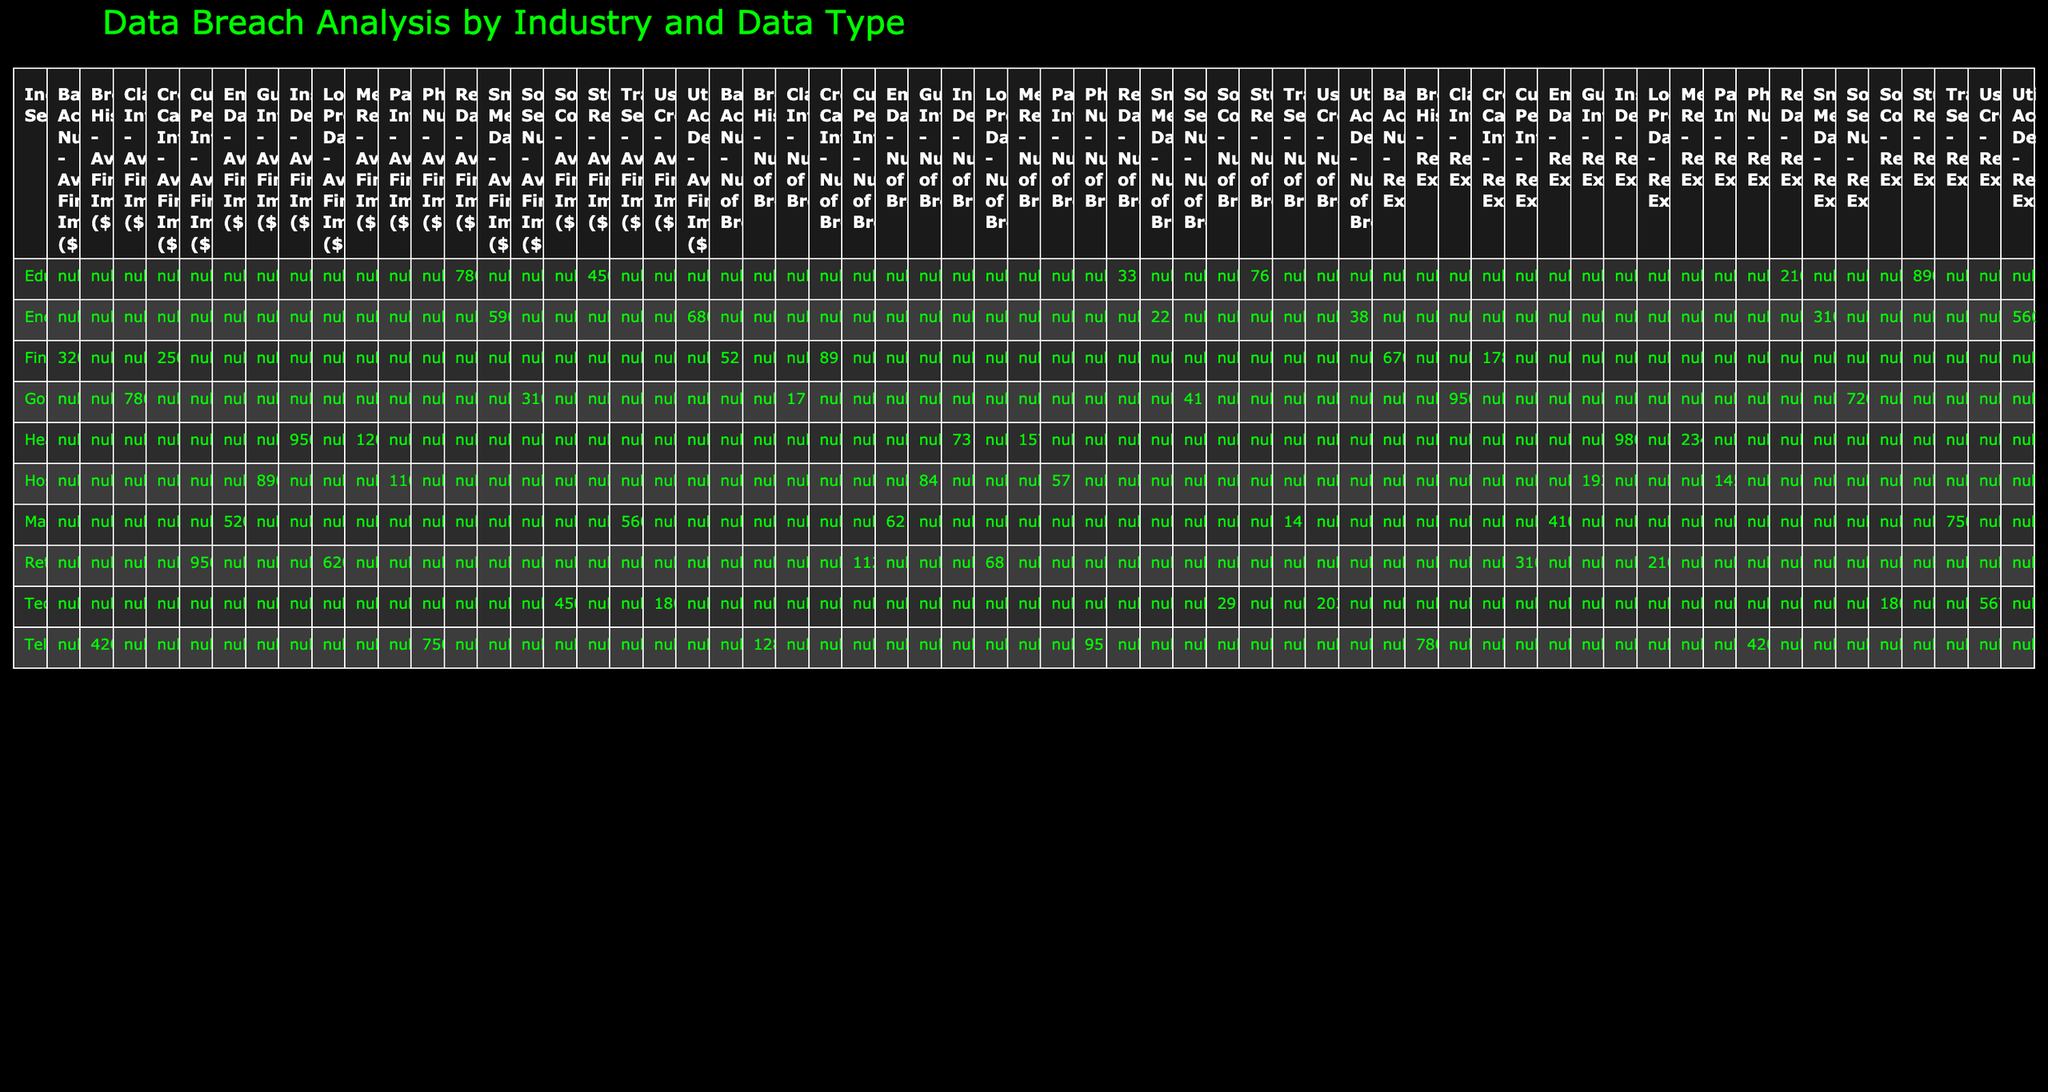What industry sector had the highest number of breaches? By looking at the "Number of Breaches" column for each industry sector, the Technology sector has the highest count with 203 breaches.
Answer: Technology What is the average financial impact of data breaches in the Government sector? The average financial impact for the Government sector is given as $3,100,000 for Social Security Numbers and $7,800,000 for Classified Information. To find the average, we calculate (3,100,000 + 7,800,000) / 2 = 5,450,000.
Answer: 5,450,000 Which data type in the Healthcare sector had the most records exposed? In the Healthcare sector, the Medical Records had 2,345,000 records exposed, while the Insurance Details had 980,000 records exposed. Therefore, Medical Records had the most records exposed.
Answer: Medical Records Did the Retail sector have more breaches of Customer Personal Info than Technology had user credentials breaches? The Retail sector had 112 breaches of Customer Personal Info, while the Technology sector had 203 breaches of user credentials. Since 112 < 203, the statement is false.
Answer: No What was the total number of records exposed across all sectors for Employee Data? The only sector with Employee Data is Manufacturing, which had 410,000 records exposed. Therefore, the total number of records exposed for this data type is 410,000.
Answer: 410,000 What sector had the least number of breaches for Utility Account Details? The only sector that reported breaches for Utility Account Details is Energy, with 38 breaches. Since no other sector is listed for this data type, Energy has the least number of breaches in this category.
Answer: Energy Which data type from the Telecommunications sector had the highest number of breaches? In the Telecommunications sector, Browsing History had the highest number of breaches with 128, compared to Phone Numbers with 95.
Answer: Browsing History What is the total number of breaches when combining the Finance sector data types? The Finance sector has breaches in two categories: Credit Card Information (89) and Bank Account Numbers (52). Summing these gives 89 + 52 = 141, which is the total number of breaches.
Answer: 141 How many sectors had more than 100 breaches total? The sectors that had more than 100 breaches are Technology (203), Healthcare (157), Finance (141), and Retail (112). There are 4 sectors in total that meet this criterion.
Answer: 4 